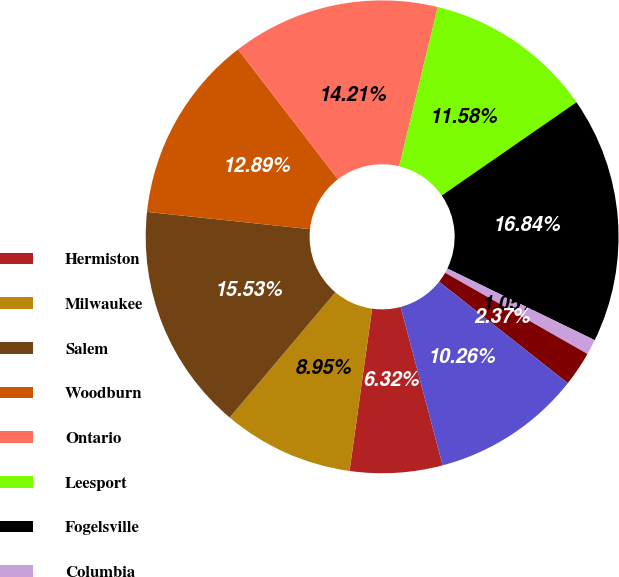<chart> <loc_0><loc_0><loc_500><loc_500><pie_chart><fcel>Hermiston<fcel>Milwaukee<fcel>Salem<fcel>Woodburn<fcel>Ontario<fcel>Leesport<fcel>Fogelsville<fcel>Columbia<fcel>Sioux Falls<fcel>Memphis<nl><fcel>6.32%<fcel>8.95%<fcel>15.53%<fcel>12.89%<fcel>14.21%<fcel>11.58%<fcel>16.84%<fcel>1.05%<fcel>2.37%<fcel>10.26%<nl></chart> 